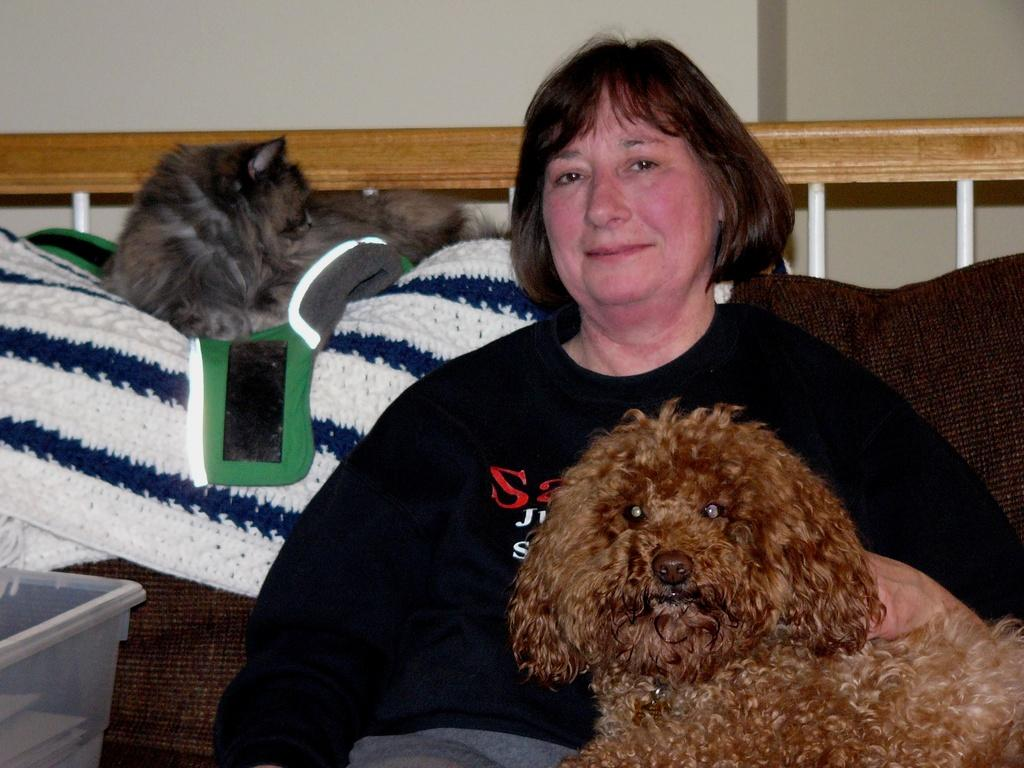Who is present in the image? There is a woman in the image. What is the woman doing in the image? The woman is sitting on a couch in the image. What is the woman holding in the image? The woman is holding a dog in the image. Can you describe the background of the image? There is a dog on a blanket in the background of the image. What type of fork is being used by the dog in the image? There is no fork present in the image, and the dog is not using any utensils. 